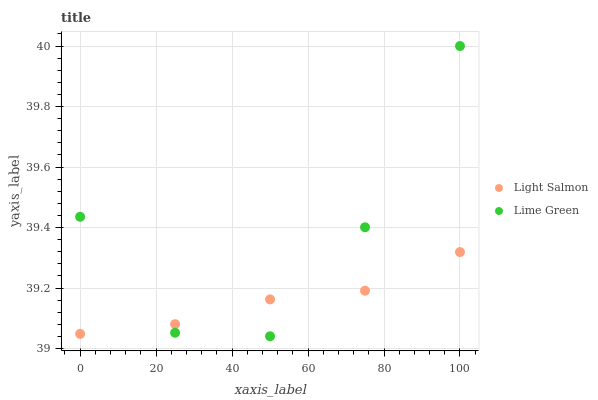Does Light Salmon have the minimum area under the curve?
Answer yes or no. Yes. Does Lime Green have the maximum area under the curve?
Answer yes or no. Yes. Does Lime Green have the minimum area under the curve?
Answer yes or no. No. Is Light Salmon the smoothest?
Answer yes or no. Yes. Is Lime Green the roughest?
Answer yes or no. Yes. Is Lime Green the smoothest?
Answer yes or no. No. Does Lime Green have the lowest value?
Answer yes or no. Yes. Does Lime Green have the highest value?
Answer yes or no. Yes. Does Light Salmon intersect Lime Green?
Answer yes or no. Yes. Is Light Salmon less than Lime Green?
Answer yes or no. No. Is Light Salmon greater than Lime Green?
Answer yes or no. No. 